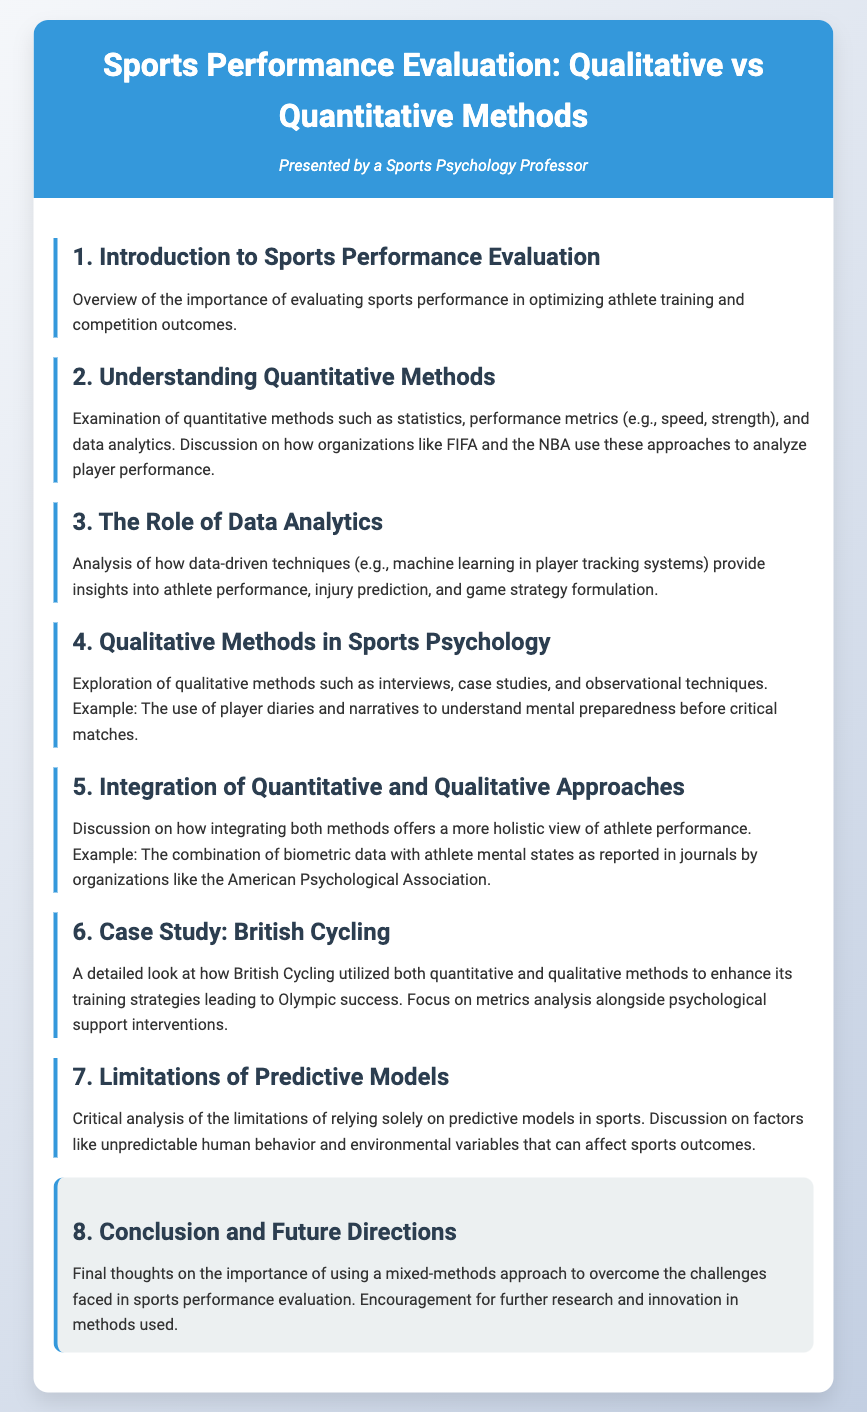What is the title of the document? The title is prominently displayed at the top of the document, and it indicates the main topic being discussed.
Answer: Sports Performance Evaluation: Qualitative vs Quantitative Methods Who presented the document? The persona section indicates the individual or role presenting the agenda, providing insight into the perspective of the document.
Answer: Sports Psychology Professor What is discussed in section 4? This section focuses on qualitative methods in sports psychology, detailing specific techniques used in evaluations.
Answer: Qualitative Methods in Sports Psychology In which section is British Cycling mentioned? The case study of British Cycling is discussed in a dedicated section that examines its use of various methods for improvement.
Answer: Section 6 What is a key limitation mentioned regarding predictive models? The limitations revolve around unpredictable factors that affect sports outcomes, highlighting the challenges faced by predictive modeling.
Answer: Unpredictable human behavior What does the conclusion emphasize? The conclusion section summarizes the document's key takeaway regarding the approach to sports performance evaluation.
Answer: Mixed-methods approach What are two examples of quantitative methods discussed? This question seeks to identify specific quantitative methods mentioned and their relevance to sports performance analysis.
Answer: Statistics and performance metrics Which organization is cited in the integration of methods? The discussion on integrating methods references a well-known organization known for psychological research in sports.
Answer: American Psychological Association 